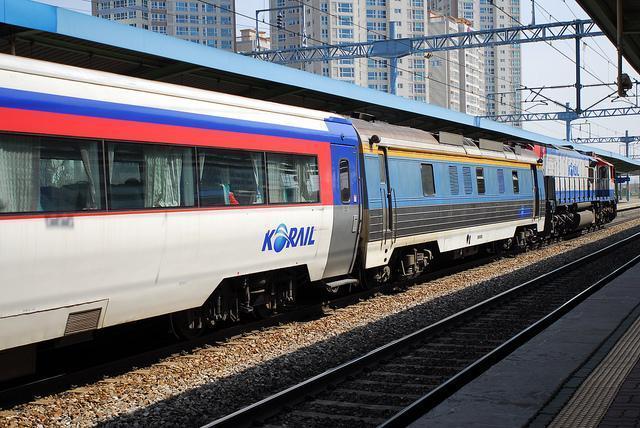How many train cars?
Give a very brief answer. 3. 